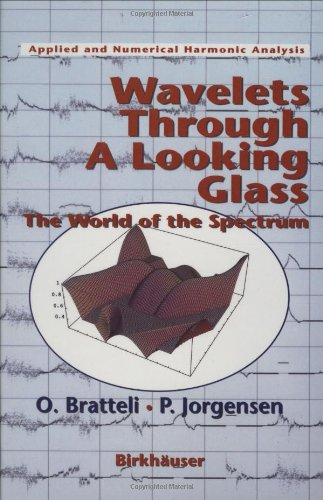Is this a digital technology book? While it discusses wavelets that can be applied in digital technologies, the book itself focuses more on the theoretical, mathematical, and physical aspects of these functions and their applications. 